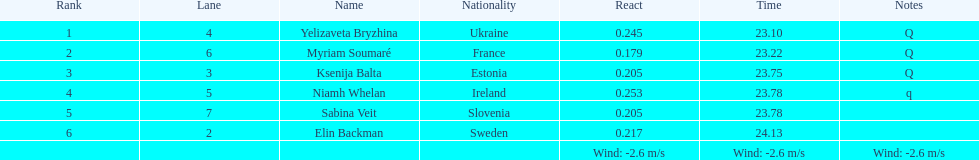Who is the top-ranked player? Yelizaveta Bryzhina. 